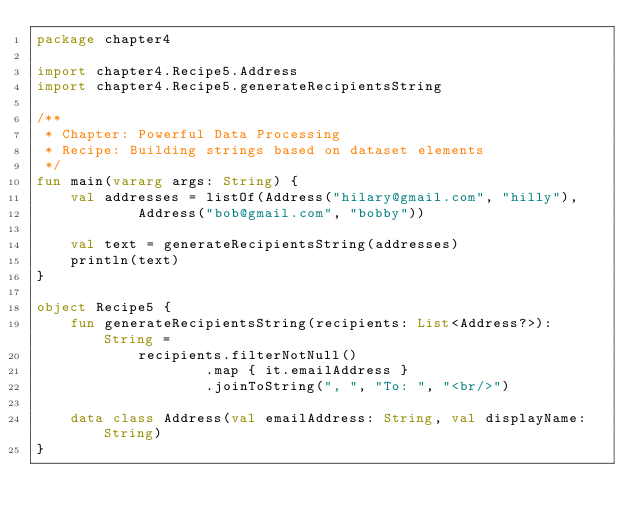Convert code to text. <code><loc_0><loc_0><loc_500><loc_500><_Kotlin_>package chapter4

import chapter4.Recipe5.Address
import chapter4.Recipe5.generateRecipientsString

/**
 * Chapter: Powerful Data Processing
 * Recipe: Building strings based on dataset elements
 */
fun main(vararg args: String) {
    val addresses = listOf(Address("hilary@gmail.com", "hilly"),
            Address("bob@gmail.com", "bobby"))

    val text = generateRecipientsString(addresses)
    println(text)
}

object Recipe5 {
    fun generateRecipientsString(recipients: List<Address?>): String =
            recipients.filterNotNull()
                    .map { it.emailAddress }
                    .joinToString(", ", "To: ", "<br/>")

    data class Address(val emailAddress: String, val displayName: String)
}
</code> 